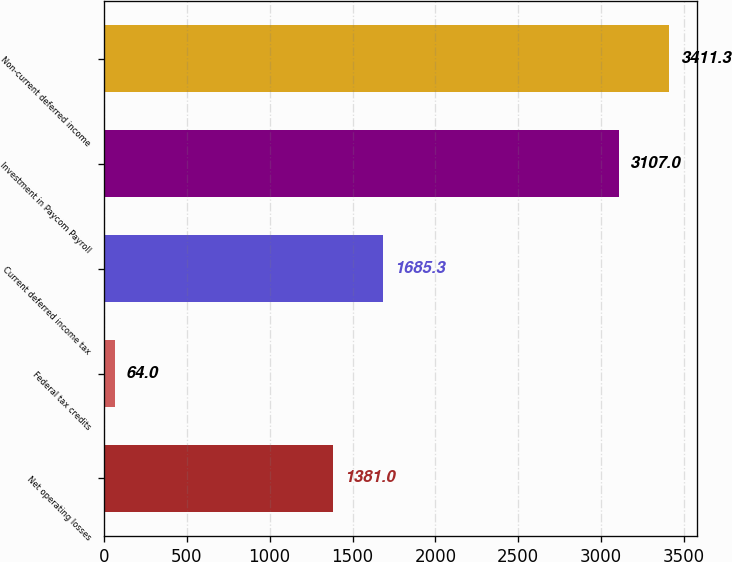Convert chart. <chart><loc_0><loc_0><loc_500><loc_500><bar_chart><fcel>Net operating losses<fcel>Federal tax credits<fcel>Current deferred income tax<fcel>Investment in Paycom Payroll<fcel>Non-current deferred income<nl><fcel>1381<fcel>64<fcel>1685.3<fcel>3107<fcel>3411.3<nl></chart> 